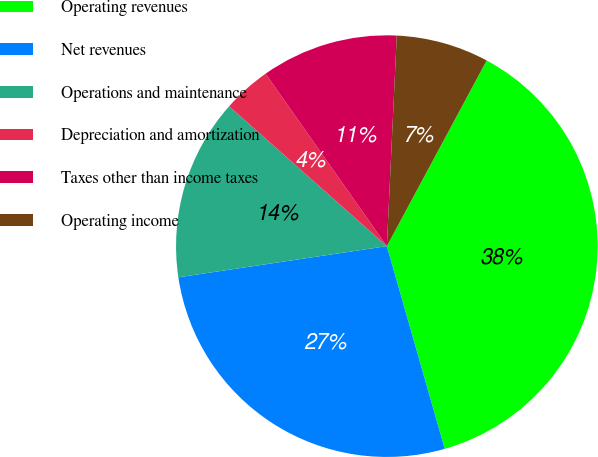<chart> <loc_0><loc_0><loc_500><loc_500><pie_chart><fcel>Operating revenues<fcel>Net revenues<fcel>Operations and maintenance<fcel>Depreciation and amortization<fcel>Taxes other than income taxes<fcel>Operating income<nl><fcel>37.72%<fcel>27.06%<fcel>13.91%<fcel>3.7%<fcel>10.5%<fcel>7.1%<nl></chart> 